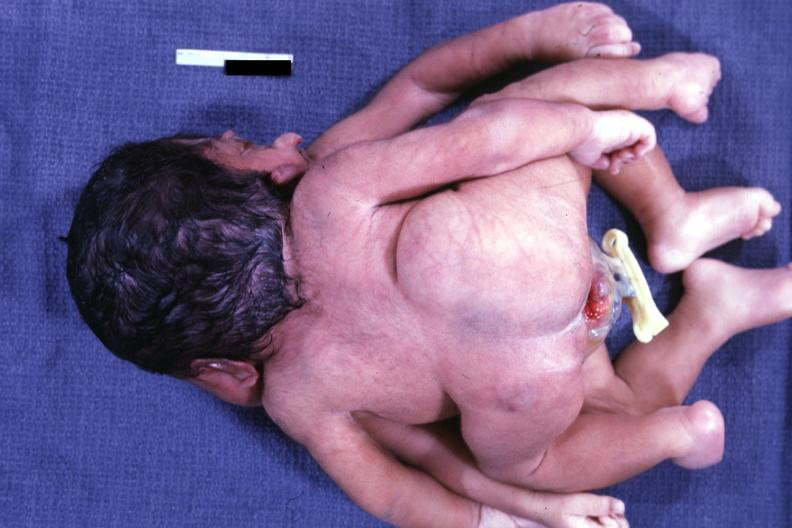does this image show posterior view?
Answer the question using a single word or phrase. Yes 